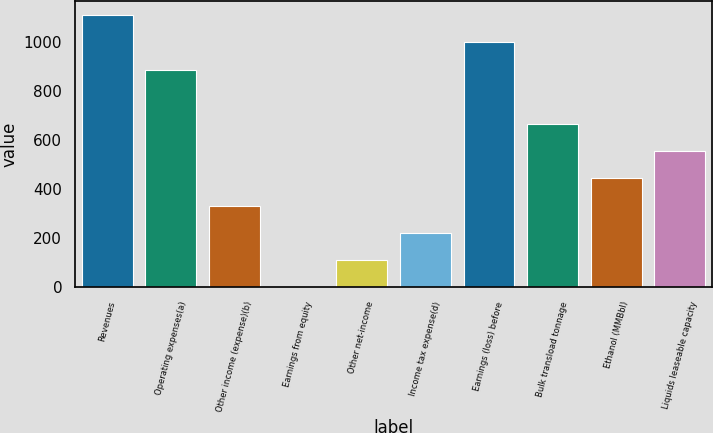Convert chart. <chart><loc_0><loc_0><loc_500><loc_500><bar_chart><fcel>Revenues<fcel>Operating expenses(a)<fcel>Other income (expense)(b)<fcel>Earnings from equity<fcel>Other net-income<fcel>Income tax expense(d)<fcel>Earnings (loss) before<fcel>Bulk transload tonnage<fcel>Ethanol (MMBbl)<fcel>Liquids leaseable capacity<nl><fcel>1109<fcel>887.34<fcel>333.19<fcel>0.7<fcel>111.53<fcel>222.36<fcel>998.17<fcel>665.68<fcel>444.02<fcel>554.85<nl></chart> 